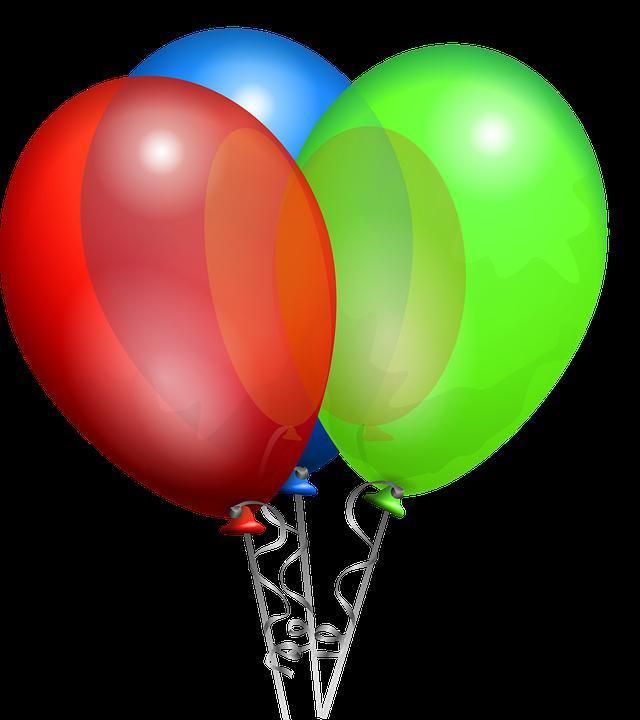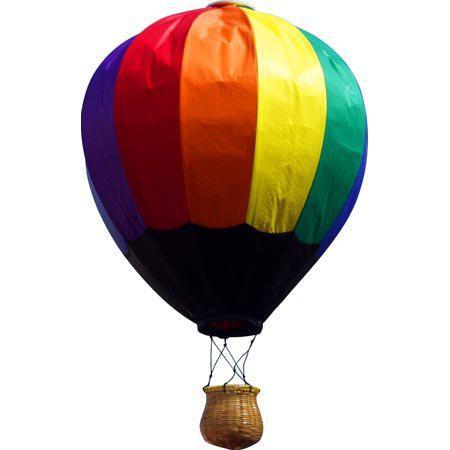The first image is the image on the left, the second image is the image on the right. Analyze the images presented: Is the assertion "No images show balloons against blue sky." valid? Answer yes or no. Yes. 